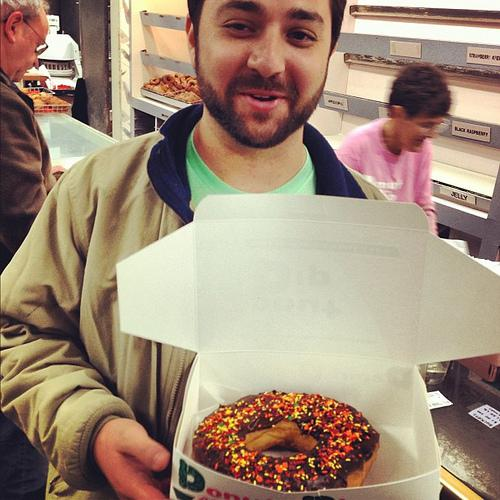Question: what food item is in the box?
Choices:
A. Bagel.
B. Sandwich.
C. Meatloaf.
D. Doughnut.
Answer with the letter. Answer: D Question: what flavor frosting is on the doughnut?
Choices:
A. Chocolate.
B. Strawberry.
C. Mint.
D. Cherry.
Answer with the letter. Answer: A Question: how many doughnuts are in the box?
Choices:
A. Two.
B. Three.
C. One.
D. Four.
Answer with the letter. Answer: C Question: who is holding the box?
Choices:
A. Child.
B. Woman.
C. Man.
D. Kid.
Answer with the letter. Answer: C Question: what color shirt is the man with the box wearing?
Choices:
A. Black.
B. Yellow.
C. Red.
D. Green.
Answer with the letter. Answer: D Question: what color hair does the man with the box have?
Choices:
A. Brown.
B. Blond.
C. Red.
D. Black.
Answer with the letter. Answer: A 